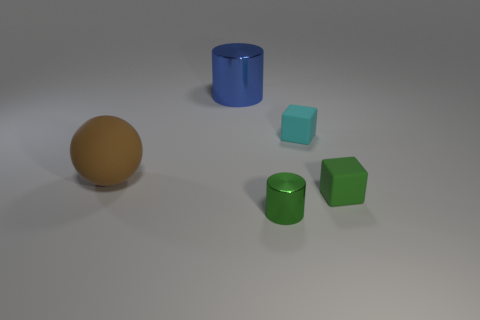There is a small cylinder; does it have the same color as the tiny cube in front of the sphere?
Make the answer very short. Yes. What size is the object that is made of the same material as the tiny green cylinder?
Your answer should be very brief. Large. There is a matte thing that is the same color as the tiny shiny cylinder; what is its size?
Your answer should be very brief. Small. Is the tiny metallic object the same color as the big rubber thing?
Offer a very short reply. No. Is there a green cube to the left of the green cylinder in front of the green object right of the small cyan object?
Offer a terse response. No. What number of brown rubber blocks have the same size as the green metal cylinder?
Your answer should be very brief. 0. There is a metallic thing in front of the blue thing; is it the same size as the shiny cylinder that is behind the green cylinder?
Provide a short and direct response. No. There is a thing that is behind the big brown rubber object and in front of the blue shiny cylinder; what shape is it?
Your answer should be very brief. Cube. Are there any small metallic objects of the same color as the ball?
Give a very brief answer. No. Are any small gray metallic blocks visible?
Ensure brevity in your answer.  No. 